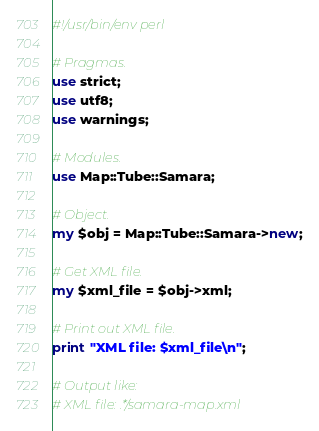<code> <loc_0><loc_0><loc_500><loc_500><_Perl_>#!/usr/bin/env perl

# Pragmas.
use strict;
use utf8;
use warnings;

# Modules.
use Map::Tube::Samara;

# Object.
my $obj = Map::Tube::Samara->new;

# Get XML file.
my $xml_file = $obj->xml;

# Print out XML file.
print "XML file: $xml_file\n";

# Output like:
# XML file: .*/samara-map.xml</code> 